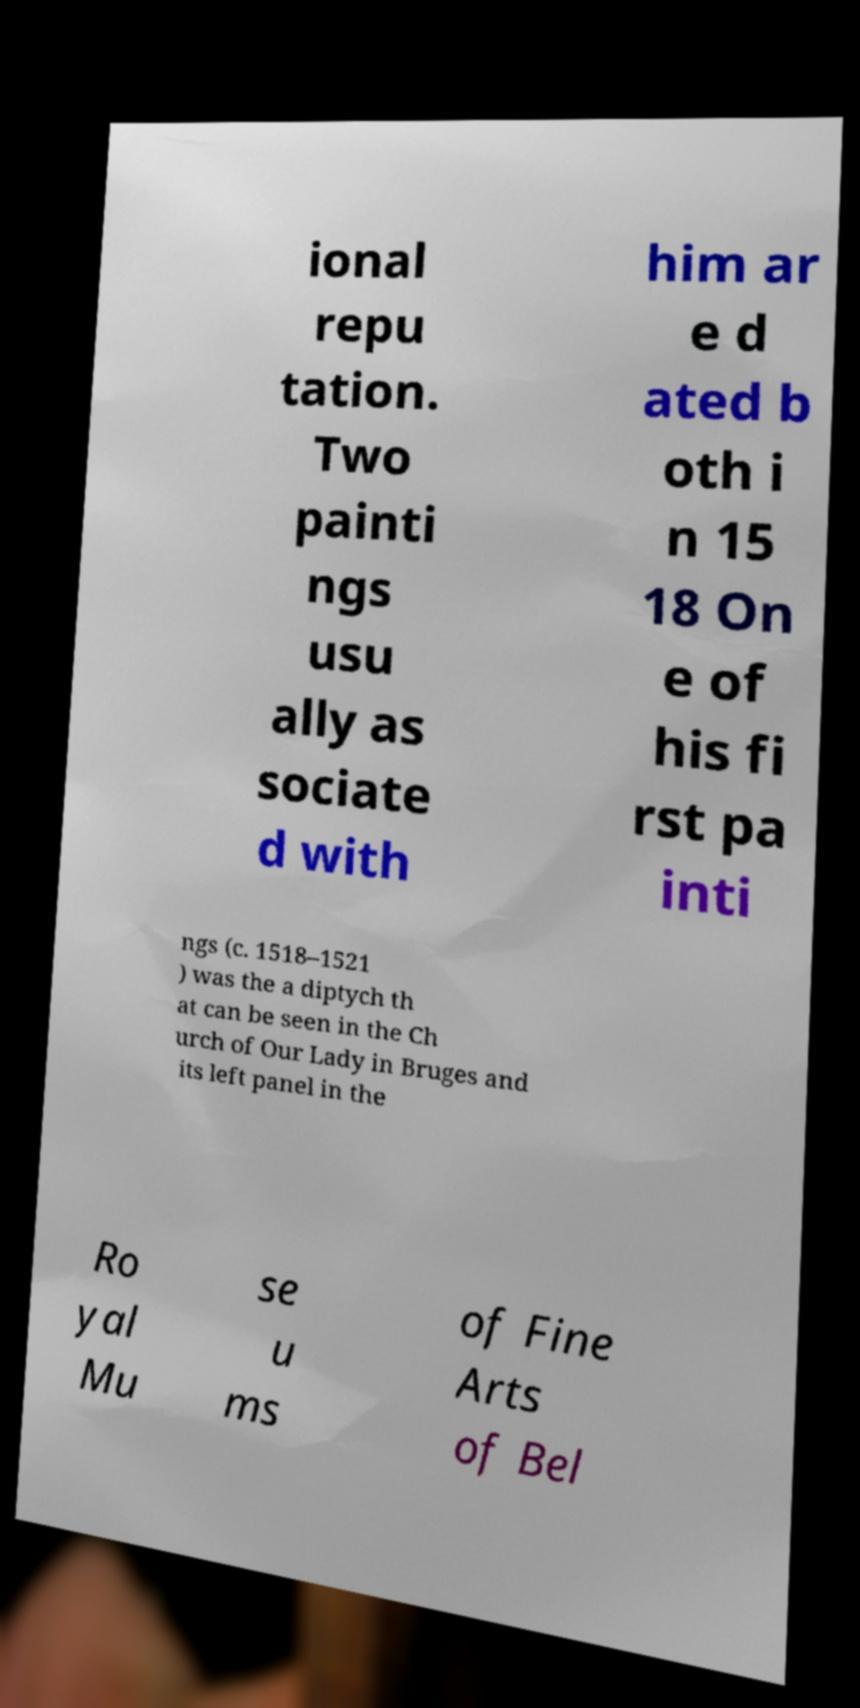Please read and relay the text visible in this image. What does it say? ional repu tation. Two painti ngs usu ally as sociate d with him ar e d ated b oth i n 15 18 On e of his fi rst pa inti ngs (c. 1518–1521 ) was the a diptych th at can be seen in the Ch urch of Our Lady in Bruges and its left panel in the Ro yal Mu se u ms of Fine Arts of Bel 